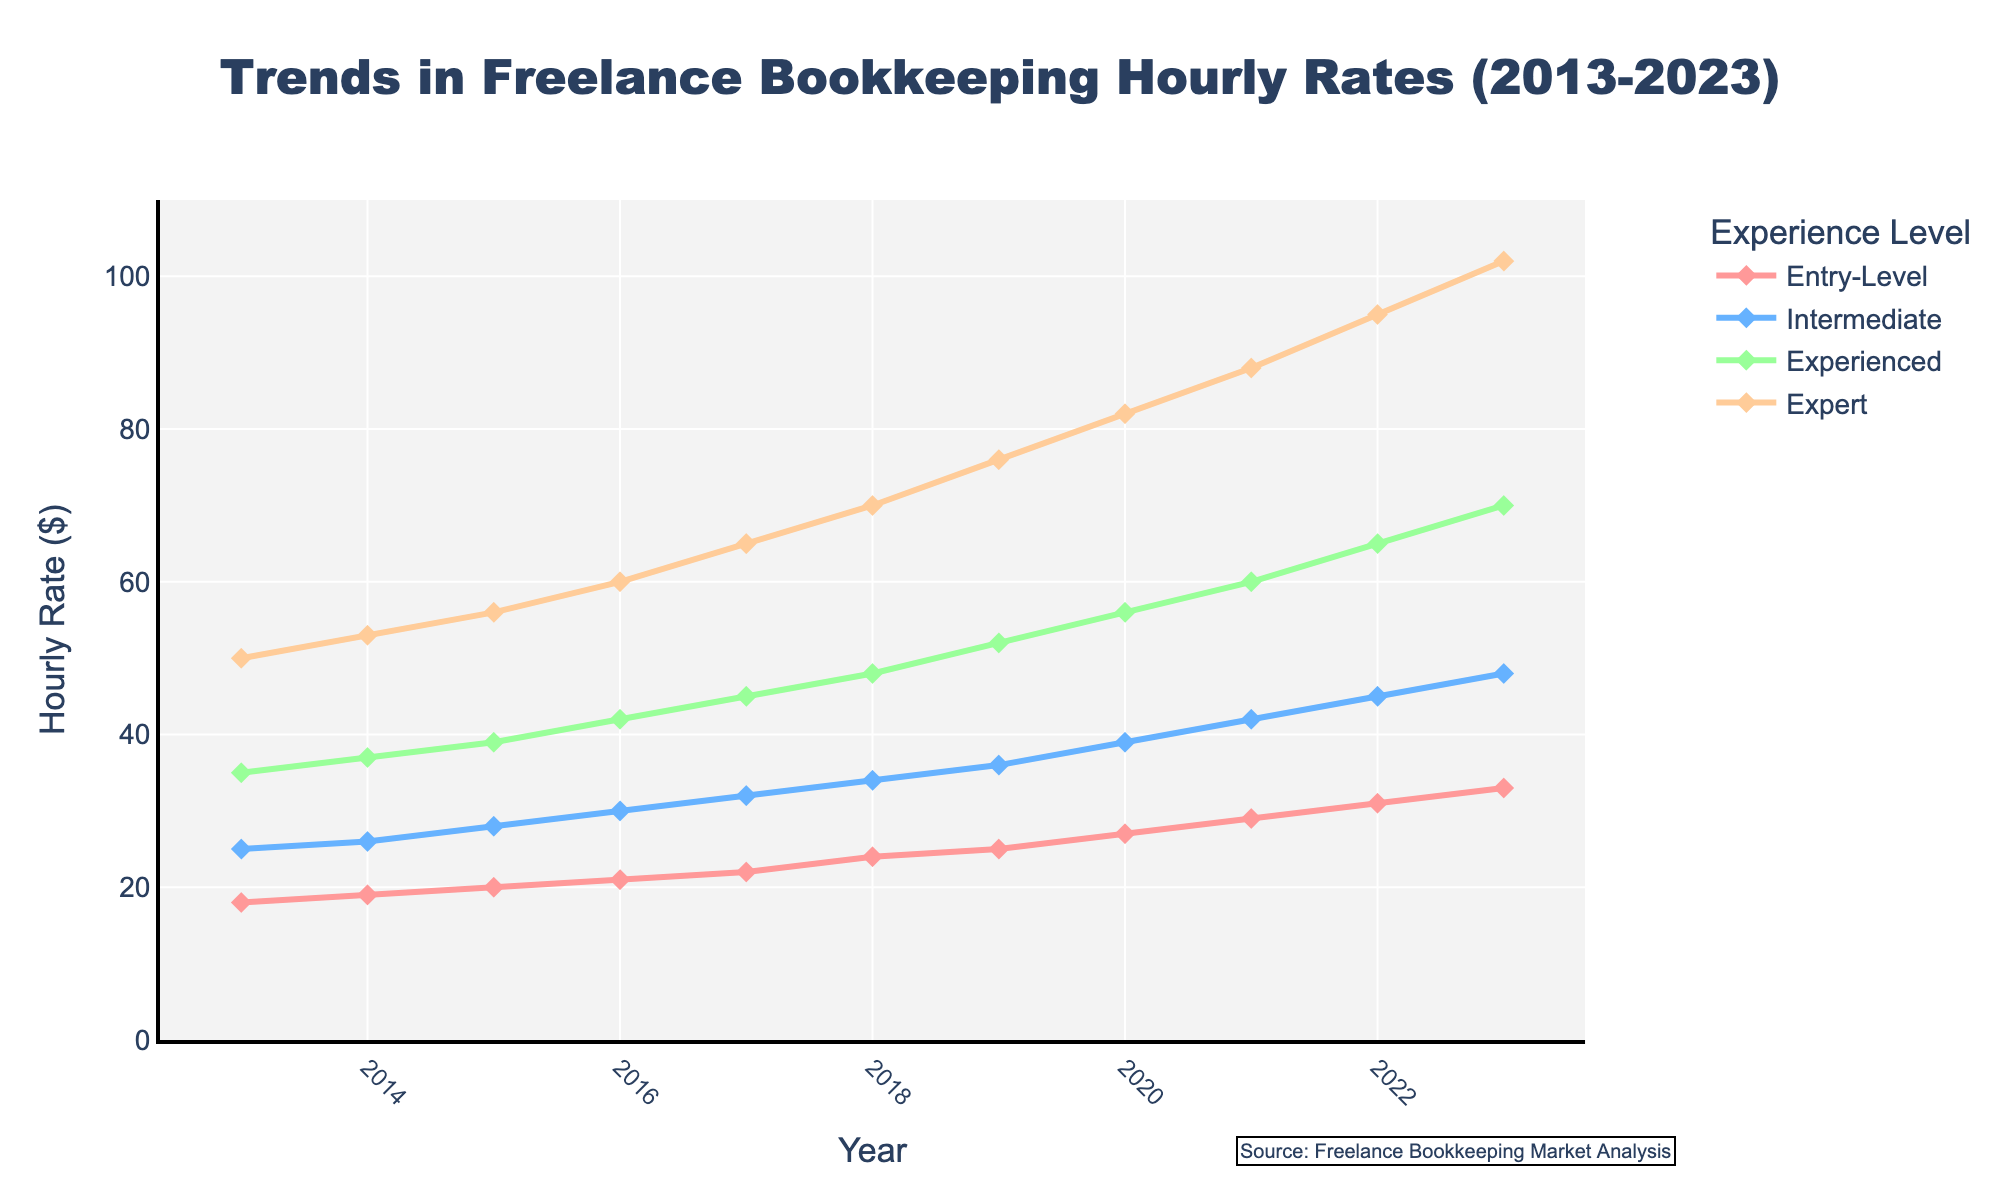What's the hourly rate for Expert-level freelancers in 2023? Locate the point for the year 2023 on the x-axis and trace it upward to the "Expert" line marked in one of the colors (orange).
Answer: 102 Which experience level had the highest hourly rate in 2017? Identify the lines representing different experience levels and compare their heights at the year 2017. The line for "Expert" (orange) is the highest.
Answer: Expert How much did the hourly rate for Intermediate-level freelancers change from 2013 to 2023? Compare the value for Intermediate level in 2013 and 2023. Subtract the 2013 value (25) from the 2023 value (48).
Answer: 23 What was the average hourly rate for Entry-Level freelancers across the entire period? Sum the hourly rates for Entry-Level freelancers from 2013 to 2023 and divide by the number of years. (18+19+20+21+22+24+25+27+29+31+33) / 11 = 249 / 11
Answer: 22.64 Which year showed the largest increase in hourly rates for Experienced-level freelancers compared to the previous year? Calculate the year-to-year increase for the Experienced level and identify the year with the largest increase. E.g., (42-39)=3, (45-42)=3, (48-45)=3,... The largest increase is from 76 in 2019 to 82 in 2020, implying an increase of 6.
Answer: 2020 How does the increase in hourly rate compare between Entry-Level and Expert freelancers from 2013 to 2023? Compare the difference between the 2023 rate and the 2013 rate for both levels (33-18=15 for Entry-Level, 102-50=52 for Expert) to determine that the increase for Expert is higher.
Answer: Expert had higher increase Which two experience levels had the closest hourly rates in 2020? Look at the rates for all four experience levels in 2020 and identify the two levels with the smallest difference: Entry-Level (27), Intermediate (39), Experienced (56), Expert (82). Compute differences:
Answer: Entry-Level and Intermediate What is the difference between the hourly rates of Intermediate and Experienced-level freelancers in 2022? Identify their rates in 2022 and subtract Intermediate rate from Experienced rate. 65 - 45 = 20.
Answer: 20 